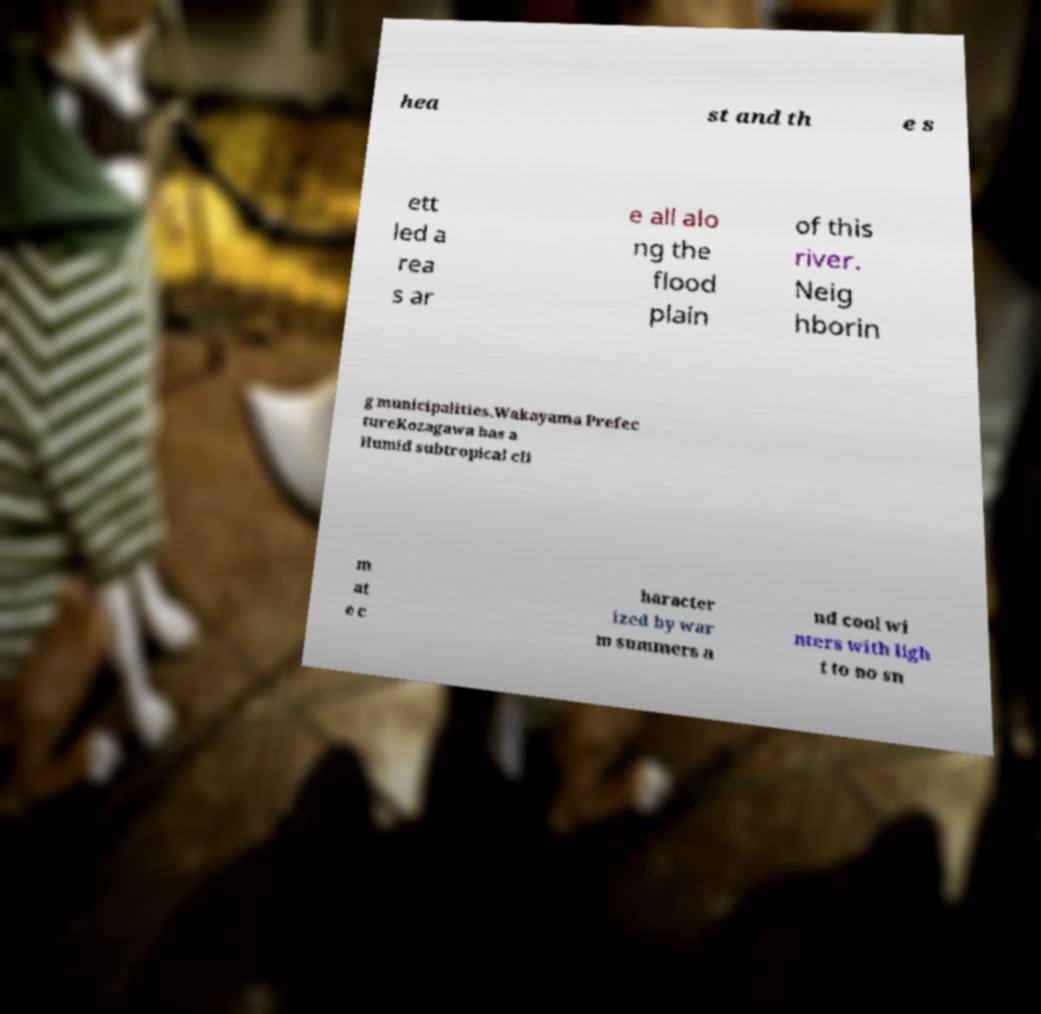Could you extract and type out the text from this image? hea st and th e s ett led a rea s ar e all alo ng the flood plain of this river. Neig hborin g municipalities.Wakayama Prefec tureKozagawa has a Humid subtropical cli m at e c haracter ized by war m summers a nd cool wi nters with ligh t to no sn 